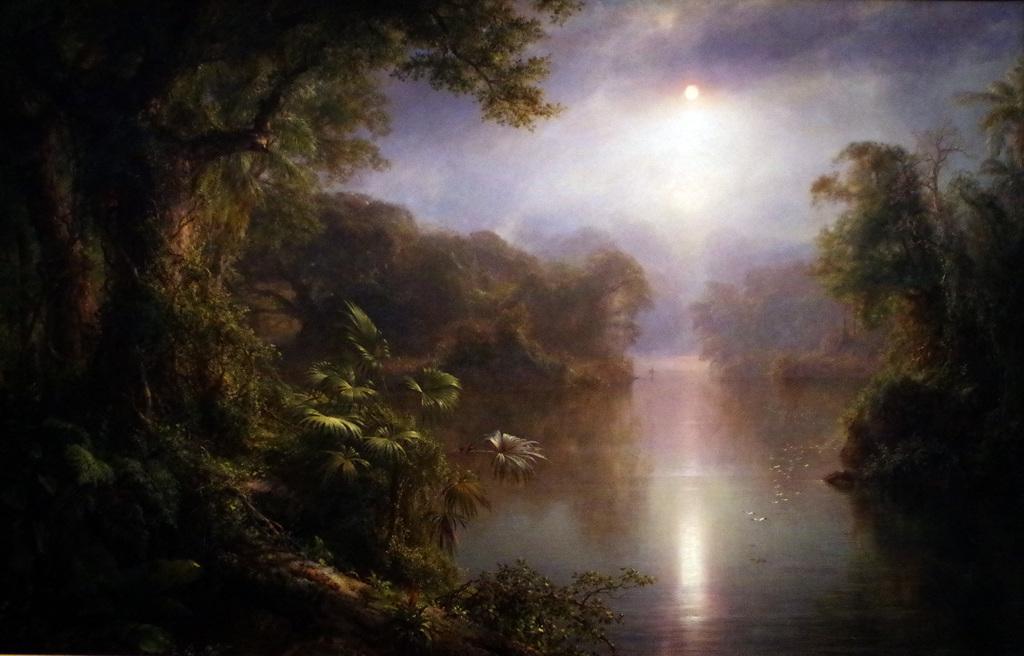In one or two sentences, can you explain what this image depicts? In this image we can see the trees, plants and also the water. We can also see the sky with the clouds and also the sun. 